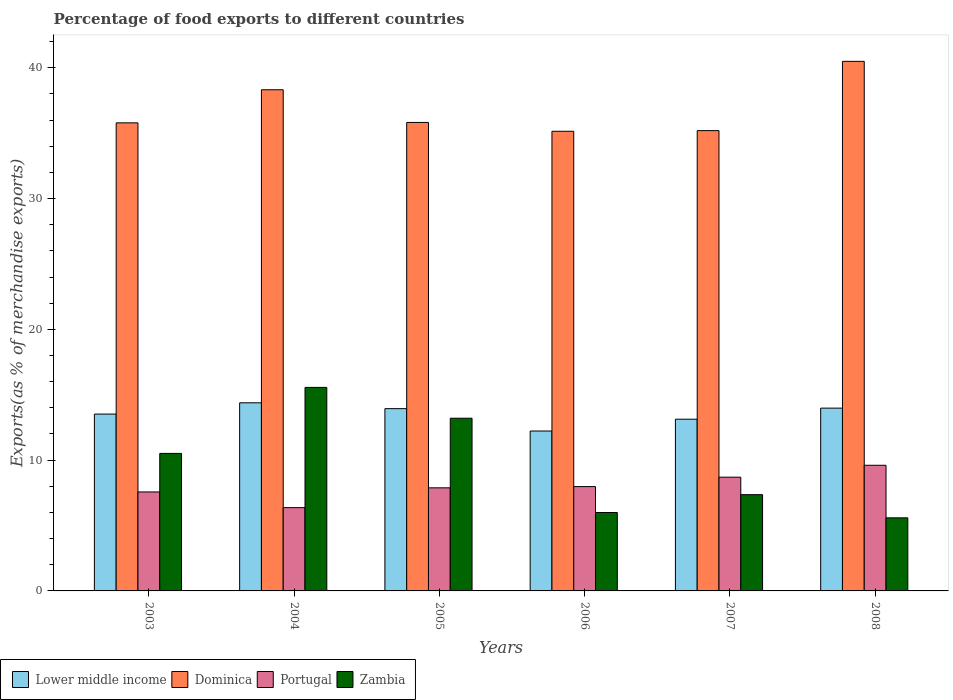How many different coloured bars are there?
Provide a short and direct response. 4. How many groups of bars are there?
Your answer should be compact. 6. Are the number of bars on each tick of the X-axis equal?
Make the answer very short. Yes. What is the label of the 1st group of bars from the left?
Your answer should be very brief. 2003. What is the percentage of exports to different countries in Portugal in 2004?
Give a very brief answer. 6.37. Across all years, what is the maximum percentage of exports to different countries in Dominica?
Offer a terse response. 40.5. Across all years, what is the minimum percentage of exports to different countries in Zambia?
Your answer should be compact. 5.59. What is the total percentage of exports to different countries in Lower middle income in the graph?
Ensure brevity in your answer.  81.18. What is the difference between the percentage of exports to different countries in Dominica in 2003 and that in 2006?
Provide a succinct answer. 0.64. What is the difference between the percentage of exports to different countries in Zambia in 2005 and the percentage of exports to different countries in Portugal in 2004?
Offer a terse response. 6.84. What is the average percentage of exports to different countries in Portugal per year?
Keep it short and to the point. 8.02. In the year 2005, what is the difference between the percentage of exports to different countries in Portugal and percentage of exports to different countries in Zambia?
Your answer should be very brief. -5.32. What is the ratio of the percentage of exports to different countries in Lower middle income in 2007 to that in 2008?
Provide a short and direct response. 0.94. Is the percentage of exports to different countries in Zambia in 2003 less than that in 2004?
Give a very brief answer. Yes. What is the difference between the highest and the second highest percentage of exports to different countries in Dominica?
Offer a very short reply. 2.17. What is the difference between the highest and the lowest percentage of exports to different countries in Zambia?
Ensure brevity in your answer.  9.97. In how many years, is the percentage of exports to different countries in Zambia greater than the average percentage of exports to different countries in Zambia taken over all years?
Provide a succinct answer. 3. Is the sum of the percentage of exports to different countries in Zambia in 2004 and 2005 greater than the maximum percentage of exports to different countries in Portugal across all years?
Your answer should be very brief. Yes. What does the 3rd bar from the left in 2006 represents?
Make the answer very short. Portugal. Is it the case that in every year, the sum of the percentage of exports to different countries in Dominica and percentage of exports to different countries in Lower middle income is greater than the percentage of exports to different countries in Zambia?
Your response must be concise. Yes. Are all the bars in the graph horizontal?
Provide a succinct answer. No. What is the difference between two consecutive major ticks on the Y-axis?
Give a very brief answer. 10. How many legend labels are there?
Your answer should be compact. 4. How are the legend labels stacked?
Provide a succinct answer. Horizontal. What is the title of the graph?
Offer a terse response. Percentage of food exports to different countries. What is the label or title of the X-axis?
Provide a short and direct response. Years. What is the label or title of the Y-axis?
Offer a very short reply. Exports(as % of merchandise exports). What is the Exports(as % of merchandise exports) of Lower middle income in 2003?
Provide a succinct answer. 13.52. What is the Exports(as % of merchandise exports) in Dominica in 2003?
Ensure brevity in your answer.  35.79. What is the Exports(as % of merchandise exports) of Portugal in 2003?
Offer a terse response. 7.57. What is the Exports(as % of merchandise exports) of Zambia in 2003?
Offer a very short reply. 10.52. What is the Exports(as % of merchandise exports) of Lower middle income in 2004?
Ensure brevity in your answer.  14.38. What is the Exports(as % of merchandise exports) of Dominica in 2004?
Ensure brevity in your answer.  38.32. What is the Exports(as % of merchandise exports) in Portugal in 2004?
Your response must be concise. 6.37. What is the Exports(as % of merchandise exports) in Zambia in 2004?
Give a very brief answer. 15.56. What is the Exports(as % of merchandise exports) of Lower middle income in 2005?
Ensure brevity in your answer.  13.94. What is the Exports(as % of merchandise exports) in Dominica in 2005?
Keep it short and to the point. 35.83. What is the Exports(as % of merchandise exports) in Portugal in 2005?
Keep it short and to the point. 7.88. What is the Exports(as % of merchandise exports) in Zambia in 2005?
Your answer should be compact. 13.21. What is the Exports(as % of merchandise exports) of Lower middle income in 2006?
Offer a very short reply. 12.23. What is the Exports(as % of merchandise exports) in Dominica in 2006?
Your answer should be very brief. 35.15. What is the Exports(as % of merchandise exports) of Portugal in 2006?
Provide a succinct answer. 7.98. What is the Exports(as % of merchandise exports) in Zambia in 2006?
Keep it short and to the point. 6. What is the Exports(as % of merchandise exports) in Lower middle income in 2007?
Your answer should be compact. 13.13. What is the Exports(as % of merchandise exports) of Dominica in 2007?
Provide a short and direct response. 35.2. What is the Exports(as % of merchandise exports) of Portugal in 2007?
Provide a short and direct response. 8.7. What is the Exports(as % of merchandise exports) in Zambia in 2007?
Your answer should be very brief. 7.36. What is the Exports(as % of merchandise exports) of Lower middle income in 2008?
Provide a short and direct response. 13.98. What is the Exports(as % of merchandise exports) of Dominica in 2008?
Your answer should be compact. 40.5. What is the Exports(as % of merchandise exports) in Portugal in 2008?
Offer a very short reply. 9.61. What is the Exports(as % of merchandise exports) of Zambia in 2008?
Your response must be concise. 5.59. Across all years, what is the maximum Exports(as % of merchandise exports) of Lower middle income?
Keep it short and to the point. 14.38. Across all years, what is the maximum Exports(as % of merchandise exports) in Dominica?
Provide a succinct answer. 40.5. Across all years, what is the maximum Exports(as % of merchandise exports) of Portugal?
Make the answer very short. 9.61. Across all years, what is the maximum Exports(as % of merchandise exports) of Zambia?
Offer a terse response. 15.56. Across all years, what is the minimum Exports(as % of merchandise exports) in Lower middle income?
Make the answer very short. 12.23. Across all years, what is the minimum Exports(as % of merchandise exports) of Dominica?
Provide a short and direct response. 35.15. Across all years, what is the minimum Exports(as % of merchandise exports) of Portugal?
Ensure brevity in your answer.  6.37. Across all years, what is the minimum Exports(as % of merchandise exports) in Zambia?
Your answer should be very brief. 5.59. What is the total Exports(as % of merchandise exports) in Lower middle income in the graph?
Make the answer very short. 81.18. What is the total Exports(as % of merchandise exports) of Dominica in the graph?
Ensure brevity in your answer.  220.79. What is the total Exports(as % of merchandise exports) of Portugal in the graph?
Ensure brevity in your answer.  48.11. What is the total Exports(as % of merchandise exports) in Zambia in the graph?
Give a very brief answer. 58.23. What is the difference between the Exports(as % of merchandise exports) in Lower middle income in 2003 and that in 2004?
Provide a succinct answer. -0.86. What is the difference between the Exports(as % of merchandise exports) of Dominica in 2003 and that in 2004?
Provide a short and direct response. -2.53. What is the difference between the Exports(as % of merchandise exports) of Portugal in 2003 and that in 2004?
Provide a succinct answer. 1.2. What is the difference between the Exports(as % of merchandise exports) in Zambia in 2003 and that in 2004?
Offer a terse response. -5.05. What is the difference between the Exports(as % of merchandise exports) in Lower middle income in 2003 and that in 2005?
Offer a very short reply. -0.41. What is the difference between the Exports(as % of merchandise exports) of Dominica in 2003 and that in 2005?
Provide a succinct answer. -0.03. What is the difference between the Exports(as % of merchandise exports) of Portugal in 2003 and that in 2005?
Give a very brief answer. -0.31. What is the difference between the Exports(as % of merchandise exports) in Zambia in 2003 and that in 2005?
Offer a terse response. -2.69. What is the difference between the Exports(as % of merchandise exports) in Lower middle income in 2003 and that in 2006?
Give a very brief answer. 1.3. What is the difference between the Exports(as % of merchandise exports) of Dominica in 2003 and that in 2006?
Offer a very short reply. 0.64. What is the difference between the Exports(as % of merchandise exports) of Portugal in 2003 and that in 2006?
Provide a short and direct response. -0.41. What is the difference between the Exports(as % of merchandise exports) of Zambia in 2003 and that in 2006?
Provide a short and direct response. 4.52. What is the difference between the Exports(as % of merchandise exports) of Lower middle income in 2003 and that in 2007?
Give a very brief answer. 0.39. What is the difference between the Exports(as % of merchandise exports) in Dominica in 2003 and that in 2007?
Keep it short and to the point. 0.59. What is the difference between the Exports(as % of merchandise exports) in Portugal in 2003 and that in 2007?
Offer a very short reply. -1.13. What is the difference between the Exports(as % of merchandise exports) of Zambia in 2003 and that in 2007?
Offer a terse response. 3.15. What is the difference between the Exports(as % of merchandise exports) of Lower middle income in 2003 and that in 2008?
Provide a short and direct response. -0.45. What is the difference between the Exports(as % of merchandise exports) in Dominica in 2003 and that in 2008?
Provide a succinct answer. -4.7. What is the difference between the Exports(as % of merchandise exports) in Portugal in 2003 and that in 2008?
Give a very brief answer. -2.04. What is the difference between the Exports(as % of merchandise exports) of Zambia in 2003 and that in 2008?
Your answer should be compact. 4.93. What is the difference between the Exports(as % of merchandise exports) in Lower middle income in 2004 and that in 2005?
Offer a terse response. 0.45. What is the difference between the Exports(as % of merchandise exports) in Dominica in 2004 and that in 2005?
Provide a succinct answer. 2.5. What is the difference between the Exports(as % of merchandise exports) of Portugal in 2004 and that in 2005?
Give a very brief answer. -1.51. What is the difference between the Exports(as % of merchandise exports) of Zambia in 2004 and that in 2005?
Keep it short and to the point. 2.36. What is the difference between the Exports(as % of merchandise exports) of Lower middle income in 2004 and that in 2006?
Your answer should be compact. 2.16. What is the difference between the Exports(as % of merchandise exports) of Dominica in 2004 and that in 2006?
Your response must be concise. 3.18. What is the difference between the Exports(as % of merchandise exports) of Portugal in 2004 and that in 2006?
Provide a succinct answer. -1.61. What is the difference between the Exports(as % of merchandise exports) of Zambia in 2004 and that in 2006?
Give a very brief answer. 9.57. What is the difference between the Exports(as % of merchandise exports) of Lower middle income in 2004 and that in 2007?
Your response must be concise. 1.25. What is the difference between the Exports(as % of merchandise exports) of Dominica in 2004 and that in 2007?
Keep it short and to the point. 3.12. What is the difference between the Exports(as % of merchandise exports) in Portugal in 2004 and that in 2007?
Ensure brevity in your answer.  -2.33. What is the difference between the Exports(as % of merchandise exports) of Zambia in 2004 and that in 2007?
Provide a short and direct response. 8.2. What is the difference between the Exports(as % of merchandise exports) of Lower middle income in 2004 and that in 2008?
Your answer should be very brief. 0.41. What is the difference between the Exports(as % of merchandise exports) in Dominica in 2004 and that in 2008?
Keep it short and to the point. -2.17. What is the difference between the Exports(as % of merchandise exports) in Portugal in 2004 and that in 2008?
Your answer should be very brief. -3.24. What is the difference between the Exports(as % of merchandise exports) of Zambia in 2004 and that in 2008?
Make the answer very short. 9.97. What is the difference between the Exports(as % of merchandise exports) in Lower middle income in 2005 and that in 2006?
Your answer should be very brief. 1.71. What is the difference between the Exports(as % of merchandise exports) of Dominica in 2005 and that in 2006?
Keep it short and to the point. 0.68. What is the difference between the Exports(as % of merchandise exports) of Portugal in 2005 and that in 2006?
Your response must be concise. -0.09. What is the difference between the Exports(as % of merchandise exports) in Zambia in 2005 and that in 2006?
Your answer should be compact. 7.21. What is the difference between the Exports(as % of merchandise exports) of Lower middle income in 2005 and that in 2007?
Your answer should be very brief. 0.81. What is the difference between the Exports(as % of merchandise exports) in Dominica in 2005 and that in 2007?
Your answer should be very brief. 0.63. What is the difference between the Exports(as % of merchandise exports) of Portugal in 2005 and that in 2007?
Your answer should be very brief. -0.82. What is the difference between the Exports(as % of merchandise exports) in Zambia in 2005 and that in 2007?
Your answer should be very brief. 5.85. What is the difference between the Exports(as % of merchandise exports) of Lower middle income in 2005 and that in 2008?
Offer a very short reply. -0.04. What is the difference between the Exports(as % of merchandise exports) in Dominica in 2005 and that in 2008?
Provide a succinct answer. -4.67. What is the difference between the Exports(as % of merchandise exports) in Portugal in 2005 and that in 2008?
Ensure brevity in your answer.  -1.73. What is the difference between the Exports(as % of merchandise exports) of Zambia in 2005 and that in 2008?
Provide a succinct answer. 7.62. What is the difference between the Exports(as % of merchandise exports) of Lower middle income in 2006 and that in 2007?
Offer a very short reply. -0.91. What is the difference between the Exports(as % of merchandise exports) of Dominica in 2006 and that in 2007?
Provide a succinct answer. -0.05. What is the difference between the Exports(as % of merchandise exports) in Portugal in 2006 and that in 2007?
Give a very brief answer. -0.72. What is the difference between the Exports(as % of merchandise exports) of Zambia in 2006 and that in 2007?
Provide a succinct answer. -1.36. What is the difference between the Exports(as % of merchandise exports) of Lower middle income in 2006 and that in 2008?
Ensure brevity in your answer.  -1.75. What is the difference between the Exports(as % of merchandise exports) in Dominica in 2006 and that in 2008?
Ensure brevity in your answer.  -5.35. What is the difference between the Exports(as % of merchandise exports) of Portugal in 2006 and that in 2008?
Your response must be concise. -1.63. What is the difference between the Exports(as % of merchandise exports) of Zambia in 2006 and that in 2008?
Keep it short and to the point. 0.41. What is the difference between the Exports(as % of merchandise exports) of Lower middle income in 2007 and that in 2008?
Your response must be concise. -0.85. What is the difference between the Exports(as % of merchandise exports) of Dominica in 2007 and that in 2008?
Your answer should be compact. -5.3. What is the difference between the Exports(as % of merchandise exports) of Portugal in 2007 and that in 2008?
Your answer should be very brief. -0.91. What is the difference between the Exports(as % of merchandise exports) in Zambia in 2007 and that in 2008?
Your response must be concise. 1.77. What is the difference between the Exports(as % of merchandise exports) of Lower middle income in 2003 and the Exports(as % of merchandise exports) of Dominica in 2004?
Your answer should be compact. -24.8. What is the difference between the Exports(as % of merchandise exports) of Lower middle income in 2003 and the Exports(as % of merchandise exports) of Portugal in 2004?
Offer a terse response. 7.15. What is the difference between the Exports(as % of merchandise exports) in Lower middle income in 2003 and the Exports(as % of merchandise exports) in Zambia in 2004?
Your answer should be compact. -2.04. What is the difference between the Exports(as % of merchandise exports) of Dominica in 2003 and the Exports(as % of merchandise exports) of Portugal in 2004?
Your response must be concise. 29.42. What is the difference between the Exports(as % of merchandise exports) of Dominica in 2003 and the Exports(as % of merchandise exports) of Zambia in 2004?
Your response must be concise. 20.23. What is the difference between the Exports(as % of merchandise exports) in Portugal in 2003 and the Exports(as % of merchandise exports) in Zambia in 2004?
Make the answer very short. -7.99. What is the difference between the Exports(as % of merchandise exports) of Lower middle income in 2003 and the Exports(as % of merchandise exports) of Dominica in 2005?
Offer a very short reply. -22.3. What is the difference between the Exports(as % of merchandise exports) of Lower middle income in 2003 and the Exports(as % of merchandise exports) of Portugal in 2005?
Offer a very short reply. 5.64. What is the difference between the Exports(as % of merchandise exports) of Lower middle income in 2003 and the Exports(as % of merchandise exports) of Zambia in 2005?
Keep it short and to the point. 0.32. What is the difference between the Exports(as % of merchandise exports) of Dominica in 2003 and the Exports(as % of merchandise exports) of Portugal in 2005?
Provide a succinct answer. 27.91. What is the difference between the Exports(as % of merchandise exports) in Dominica in 2003 and the Exports(as % of merchandise exports) in Zambia in 2005?
Offer a terse response. 22.59. What is the difference between the Exports(as % of merchandise exports) in Portugal in 2003 and the Exports(as % of merchandise exports) in Zambia in 2005?
Keep it short and to the point. -5.64. What is the difference between the Exports(as % of merchandise exports) in Lower middle income in 2003 and the Exports(as % of merchandise exports) in Dominica in 2006?
Offer a terse response. -21.63. What is the difference between the Exports(as % of merchandise exports) in Lower middle income in 2003 and the Exports(as % of merchandise exports) in Portugal in 2006?
Make the answer very short. 5.55. What is the difference between the Exports(as % of merchandise exports) of Lower middle income in 2003 and the Exports(as % of merchandise exports) of Zambia in 2006?
Offer a terse response. 7.53. What is the difference between the Exports(as % of merchandise exports) in Dominica in 2003 and the Exports(as % of merchandise exports) in Portugal in 2006?
Your answer should be compact. 27.82. What is the difference between the Exports(as % of merchandise exports) in Dominica in 2003 and the Exports(as % of merchandise exports) in Zambia in 2006?
Provide a short and direct response. 29.8. What is the difference between the Exports(as % of merchandise exports) in Portugal in 2003 and the Exports(as % of merchandise exports) in Zambia in 2006?
Your answer should be compact. 1.57. What is the difference between the Exports(as % of merchandise exports) in Lower middle income in 2003 and the Exports(as % of merchandise exports) in Dominica in 2007?
Provide a succinct answer. -21.68. What is the difference between the Exports(as % of merchandise exports) of Lower middle income in 2003 and the Exports(as % of merchandise exports) of Portugal in 2007?
Your response must be concise. 4.83. What is the difference between the Exports(as % of merchandise exports) in Lower middle income in 2003 and the Exports(as % of merchandise exports) in Zambia in 2007?
Keep it short and to the point. 6.16. What is the difference between the Exports(as % of merchandise exports) of Dominica in 2003 and the Exports(as % of merchandise exports) of Portugal in 2007?
Offer a terse response. 27.1. What is the difference between the Exports(as % of merchandise exports) in Dominica in 2003 and the Exports(as % of merchandise exports) in Zambia in 2007?
Provide a short and direct response. 28.43. What is the difference between the Exports(as % of merchandise exports) of Portugal in 2003 and the Exports(as % of merchandise exports) of Zambia in 2007?
Your response must be concise. 0.21. What is the difference between the Exports(as % of merchandise exports) of Lower middle income in 2003 and the Exports(as % of merchandise exports) of Dominica in 2008?
Give a very brief answer. -26.97. What is the difference between the Exports(as % of merchandise exports) in Lower middle income in 2003 and the Exports(as % of merchandise exports) in Portugal in 2008?
Your response must be concise. 3.92. What is the difference between the Exports(as % of merchandise exports) in Lower middle income in 2003 and the Exports(as % of merchandise exports) in Zambia in 2008?
Ensure brevity in your answer.  7.94. What is the difference between the Exports(as % of merchandise exports) of Dominica in 2003 and the Exports(as % of merchandise exports) of Portugal in 2008?
Make the answer very short. 26.18. What is the difference between the Exports(as % of merchandise exports) of Dominica in 2003 and the Exports(as % of merchandise exports) of Zambia in 2008?
Keep it short and to the point. 30.21. What is the difference between the Exports(as % of merchandise exports) of Portugal in 2003 and the Exports(as % of merchandise exports) of Zambia in 2008?
Offer a very short reply. 1.98. What is the difference between the Exports(as % of merchandise exports) of Lower middle income in 2004 and the Exports(as % of merchandise exports) of Dominica in 2005?
Make the answer very short. -21.44. What is the difference between the Exports(as % of merchandise exports) of Lower middle income in 2004 and the Exports(as % of merchandise exports) of Portugal in 2005?
Keep it short and to the point. 6.5. What is the difference between the Exports(as % of merchandise exports) of Lower middle income in 2004 and the Exports(as % of merchandise exports) of Zambia in 2005?
Make the answer very short. 1.18. What is the difference between the Exports(as % of merchandise exports) of Dominica in 2004 and the Exports(as % of merchandise exports) of Portugal in 2005?
Make the answer very short. 30.44. What is the difference between the Exports(as % of merchandise exports) in Dominica in 2004 and the Exports(as % of merchandise exports) in Zambia in 2005?
Make the answer very short. 25.12. What is the difference between the Exports(as % of merchandise exports) of Portugal in 2004 and the Exports(as % of merchandise exports) of Zambia in 2005?
Offer a terse response. -6.84. What is the difference between the Exports(as % of merchandise exports) in Lower middle income in 2004 and the Exports(as % of merchandise exports) in Dominica in 2006?
Your response must be concise. -20.76. What is the difference between the Exports(as % of merchandise exports) of Lower middle income in 2004 and the Exports(as % of merchandise exports) of Portugal in 2006?
Make the answer very short. 6.41. What is the difference between the Exports(as % of merchandise exports) of Lower middle income in 2004 and the Exports(as % of merchandise exports) of Zambia in 2006?
Your answer should be very brief. 8.39. What is the difference between the Exports(as % of merchandise exports) in Dominica in 2004 and the Exports(as % of merchandise exports) in Portugal in 2006?
Your answer should be very brief. 30.35. What is the difference between the Exports(as % of merchandise exports) of Dominica in 2004 and the Exports(as % of merchandise exports) of Zambia in 2006?
Your response must be concise. 32.33. What is the difference between the Exports(as % of merchandise exports) of Portugal in 2004 and the Exports(as % of merchandise exports) of Zambia in 2006?
Give a very brief answer. 0.37. What is the difference between the Exports(as % of merchandise exports) in Lower middle income in 2004 and the Exports(as % of merchandise exports) in Dominica in 2007?
Make the answer very short. -20.82. What is the difference between the Exports(as % of merchandise exports) in Lower middle income in 2004 and the Exports(as % of merchandise exports) in Portugal in 2007?
Keep it short and to the point. 5.69. What is the difference between the Exports(as % of merchandise exports) of Lower middle income in 2004 and the Exports(as % of merchandise exports) of Zambia in 2007?
Make the answer very short. 7.02. What is the difference between the Exports(as % of merchandise exports) of Dominica in 2004 and the Exports(as % of merchandise exports) of Portugal in 2007?
Your answer should be very brief. 29.63. What is the difference between the Exports(as % of merchandise exports) of Dominica in 2004 and the Exports(as % of merchandise exports) of Zambia in 2007?
Make the answer very short. 30.96. What is the difference between the Exports(as % of merchandise exports) in Portugal in 2004 and the Exports(as % of merchandise exports) in Zambia in 2007?
Offer a terse response. -0.99. What is the difference between the Exports(as % of merchandise exports) in Lower middle income in 2004 and the Exports(as % of merchandise exports) in Dominica in 2008?
Give a very brief answer. -26.11. What is the difference between the Exports(as % of merchandise exports) of Lower middle income in 2004 and the Exports(as % of merchandise exports) of Portugal in 2008?
Give a very brief answer. 4.78. What is the difference between the Exports(as % of merchandise exports) in Lower middle income in 2004 and the Exports(as % of merchandise exports) in Zambia in 2008?
Ensure brevity in your answer.  8.8. What is the difference between the Exports(as % of merchandise exports) in Dominica in 2004 and the Exports(as % of merchandise exports) in Portugal in 2008?
Offer a very short reply. 28.72. What is the difference between the Exports(as % of merchandise exports) in Dominica in 2004 and the Exports(as % of merchandise exports) in Zambia in 2008?
Ensure brevity in your answer.  32.74. What is the difference between the Exports(as % of merchandise exports) of Portugal in 2004 and the Exports(as % of merchandise exports) of Zambia in 2008?
Offer a terse response. 0.78. What is the difference between the Exports(as % of merchandise exports) in Lower middle income in 2005 and the Exports(as % of merchandise exports) in Dominica in 2006?
Make the answer very short. -21.21. What is the difference between the Exports(as % of merchandise exports) in Lower middle income in 2005 and the Exports(as % of merchandise exports) in Portugal in 2006?
Ensure brevity in your answer.  5.96. What is the difference between the Exports(as % of merchandise exports) of Lower middle income in 2005 and the Exports(as % of merchandise exports) of Zambia in 2006?
Keep it short and to the point. 7.94. What is the difference between the Exports(as % of merchandise exports) of Dominica in 2005 and the Exports(as % of merchandise exports) of Portugal in 2006?
Offer a terse response. 27.85. What is the difference between the Exports(as % of merchandise exports) of Dominica in 2005 and the Exports(as % of merchandise exports) of Zambia in 2006?
Offer a very short reply. 29.83. What is the difference between the Exports(as % of merchandise exports) of Portugal in 2005 and the Exports(as % of merchandise exports) of Zambia in 2006?
Ensure brevity in your answer.  1.89. What is the difference between the Exports(as % of merchandise exports) of Lower middle income in 2005 and the Exports(as % of merchandise exports) of Dominica in 2007?
Your answer should be compact. -21.26. What is the difference between the Exports(as % of merchandise exports) of Lower middle income in 2005 and the Exports(as % of merchandise exports) of Portugal in 2007?
Provide a short and direct response. 5.24. What is the difference between the Exports(as % of merchandise exports) in Lower middle income in 2005 and the Exports(as % of merchandise exports) in Zambia in 2007?
Your response must be concise. 6.58. What is the difference between the Exports(as % of merchandise exports) in Dominica in 2005 and the Exports(as % of merchandise exports) in Portugal in 2007?
Your response must be concise. 27.13. What is the difference between the Exports(as % of merchandise exports) of Dominica in 2005 and the Exports(as % of merchandise exports) of Zambia in 2007?
Offer a very short reply. 28.47. What is the difference between the Exports(as % of merchandise exports) of Portugal in 2005 and the Exports(as % of merchandise exports) of Zambia in 2007?
Offer a very short reply. 0.52. What is the difference between the Exports(as % of merchandise exports) in Lower middle income in 2005 and the Exports(as % of merchandise exports) in Dominica in 2008?
Make the answer very short. -26.56. What is the difference between the Exports(as % of merchandise exports) of Lower middle income in 2005 and the Exports(as % of merchandise exports) of Portugal in 2008?
Provide a short and direct response. 4.33. What is the difference between the Exports(as % of merchandise exports) in Lower middle income in 2005 and the Exports(as % of merchandise exports) in Zambia in 2008?
Your response must be concise. 8.35. What is the difference between the Exports(as % of merchandise exports) in Dominica in 2005 and the Exports(as % of merchandise exports) in Portugal in 2008?
Keep it short and to the point. 26.22. What is the difference between the Exports(as % of merchandise exports) in Dominica in 2005 and the Exports(as % of merchandise exports) in Zambia in 2008?
Your response must be concise. 30.24. What is the difference between the Exports(as % of merchandise exports) in Portugal in 2005 and the Exports(as % of merchandise exports) in Zambia in 2008?
Offer a terse response. 2.29. What is the difference between the Exports(as % of merchandise exports) of Lower middle income in 2006 and the Exports(as % of merchandise exports) of Dominica in 2007?
Your response must be concise. -22.97. What is the difference between the Exports(as % of merchandise exports) in Lower middle income in 2006 and the Exports(as % of merchandise exports) in Portugal in 2007?
Your response must be concise. 3.53. What is the difference between the Exports(as % of merchandise exports) of Lower middle income in 2006 and the Exports(as % of merchandise exports) of Zambia in 2007?
Provide a short and direct response. 4.87. What is the difference between the Exports(as % of merchandise exports) of Dominica in 2006 and the Exports(as % of merchandise exports) of Portugal in 2007?
Give a very brief answer. 26.45. What is the difference between the Exports(as % of merchandise exports) in Dominica in 2006 and the Exports(as % of merchandise exports) in Zambia in 2007?
Provide a succinct answer. 27.79. What is the difference between the Exports(as % of merchandise exports) of Portugal in 2006 and the Exports(as % of merchandise exports) of Zambia in 2007?
Your response must be concise. 0.62. What is the difference between the Exports(as % of merchandise exports) of Lower middle income in 2006 and the Exports(as % of merchandise exports) of Dominica in 2008?
Ensure brevity in your answer.  -28.27. What is the difference between the Exports(as % of merchandise exports) in Lower middle income in 2006 and the Exports(as % of merchandise exports) in Portugal in 2008?
Make the answer very short. 2.62. What is the difference between the Exports(as % of merchandise exports) in Lower middle income in 2006 and the Exports(as % of merchandise exports) in Zambia in 2008?
Provide a short and direct response. 6.64. What is the difference between the Exports(as % of merchandise exports) of Dominica in 2006 and the Exports(as % of merchandise exports) of Portugal in 2008?
Your answer should be very brief. 25.54. What is the difference between the Exports(as % of merchandise exports) of Dominica in 2006 and the Exports(as % of merchandise exports) of Zambia in 2008?
Give a very brief answer. 29.56. What is the difference between the Exports(as % of merchandise exports) in Portugal in 2006 and the Exports(as % of merchandise exports) in Zambia in 2008?
Make the answer very short. 2.39. What is the difference between the Exports(as % of merchandise exports) in Lower middle income in 2007 and the Exports(as % of merchandise exports) in Dominica in 2008?
Your answer should be very brief. -27.36. What is the difference between the Exports(as % of merchandise exports) in Lower middle income in 2007 and the Exports(as % of merchandise exports) in Portugal in 2008?
Your answer should be very brief. 3.52. What is the difference between the Exports(as % of merchandise exports) in Lower middle income in 2007 and the Exports(as % of merchandise exports) in Zambia in 2008?
Keep it short and to the point. 7.54. What is the difference between the Exports(as % of merchandise exports) in Dominica in 2007 and the Exports(as % of merchandise exports) in Portugal in 2008?
Ensure brevity in your answer.  25.59. What is the difference between the Exports(as % of merchandise exports) in Dominica in 2007 and the Exports(as % of merchandise exports) in Zambia in 2008?
Your answer should be very brief. 29.61. What is the difference between the Exports(as % of merchandise exports) of Portugal in 2007 and the Exports(as % of merchandise exports) of Zambia in 2008?
Provide a succinct answer. 3.11. What is the average Exports(as % of merchandise exports) of Lower middle income per year?
Your response must be concise. 13.53. What is the average Exports(as % of merchandise exports) of Dominica per year?
Offer a terse response. 36.8. What is the average Exports(as % of merchandise exports) in Portugal per year?
Ensure brevity in your answer.  8.02. What is the average Exports(as % of merchandise exports) in Zambia per year?
Make the answer very short. 9.71. In the year 2003, what is the difference between the Exports(as % of merchandise exports) of Lower middle income and Exports(as % of merchandise exports) of Dominica?
Provide a succinct answer. -22.27. In the year 2003, what is the difference between the Exports(as % of merchandise exports) of Lower middle income and Exports(as % of merchandise exports) of Portugal?
Offer a very short reply. 5.96. In the year 2003, what is the difference between the Exports(as % of merchandise exports) of Lower middle income and Exports(as % of merchandise exports) of Zambia?
Make the answer very short. 3.01. In the year 2003, what is the difference between the Exports(as % of merchandise exports) in Dominica and Exports(as % of merchandise exports) in Portugal?
Ensure brevity in your answer.  28.23. In the year 2003, what is the difference between the Exports(as % of merchandise exports) of Dominica and Exports(as % of merchandise exports) of Zambia?
Give a very brief answer. 25.28. In the year 2003, what is the difference between the Exports(as % of merchandise exports) in Portugal and Exports(as % of merchandise exports) in Zambia?
Your answer should be compact. -2.95. In the year 2004, what is the difference between the Exports(as % of merchandise exports) in Lower middle income and Exports(as % of merchandise exports) in Dominica?
Your response must be concise. -23.94. In the year 2004, what is the difference between the Exports(as % of merchandise exports) of Lower middle income and Exports(as % of merchandise exports) of Portugal?
Provide a short and direct response. 8.02. In the year 2004, what is the difference between the Exports(as % of merchandise exports) of Lower middle income and Exports(as % of merchandise exports) of Zambia?
Your answer should be compact. -1.18. In the year 2004, what is the difference between the Exports(as % of merchandise exports) of Dominica and Exports(as % of merchandise exports) of Portugal?
Your response must be concise. 31.96. In the year 2004, what is the difference between the Exports(as % of merchandise exports) in Dominica and Exports(as % of merchandise exports) in Zambia?
Offer a very short reply. 22.76. In the year 2004, what is the difference between the Exports(as % of merchandise exports) of Portugal and Exports(as % of merchandise exports) of Zambia?
Your answer should be very brief. -9.19. In the year 2005, what is the difference between the Exports(as % of merchandise exports) of Lower middle income and Exports(as % of merchandise exports) of Dominica?
Provide a succinct answer. -21.89. In the year 2005, what is the difference between the Exports(as % of merchandise exports) in Lower middle income and Exports(as % of merchandise exports) in Portugal?
Your answer should be very brief. 6.06. In the year 2005, what is the difference between the Exports(as % of merchandise exports) of Lower middle income and Exports(as % of merchandise exports) of Zambia?
Your answer should be compact. 0.73. In the year 2005, what is the difference between the Exports(as % of merchandise exports) of Dominica and Exports(as % of merchandise exports) of Portugal?
Ensure brevity in your answer.  27.94. In the year 2005, what is the difference between the Exports(as % of merchandise exports) of Dominica and Exports(as % of merchandise exports) of Zambia?
Your answer should be very brief. 22.62. In the year 2005, what is the difference between the Exports(as % of merchandise exports) in Portugal and Exports(as % of merchandise exports) in Zambia?
Your response must be concise. -5.32. In the year 2006, what is the difference between the Exports(as % of merchandise exports) of Lower middle income and Exports(as % of merchandise exports) of Dominica?
Keep it short and to the point. -22.92. In the year 2006, what is the difference between the Exports(as % of merchandise exports) of Lower middle income and Exports(as % of merchandise exports) of Portugal?
Offer a terse response. 4.25. In the year 2006, what is the difference between the Exports(as % of merchandise exports) in Lower middle income and Exports(as % of merchandise exports) in Zambia?
Offer a terse response. 6.23. In the year 2006, what is the difference between the Exports(as % of merchandise exports) in Dominica and Exports(as % of merchandise exports) in Portugal?
Your response must be concise. 27.17. In the year 2006, what is the difference between the Exports(as % of merchandise exports) in Dominica and Exports(as % of merchandise exports) in Zambia?
Your response must be concise. 29.15. In the year 2006, what is the difference between the Exports(as % of merchandise exports) in Portugal and Exports(as % of merchandise exports) in Zambia?
Keep it short and to the point. 1.98. In the year 2007, what is the difference between the Exports(as % of merchandise exports) in Lower middle income and Exports(as % of merchandise exports) in Dominica?
Provide a succinct answer. -22.07. In the year 2007, what is the difference between the Exports(as % of merchandise exports) of Lower middle income and Exports(as % of merchandise exports) of Portugal?
Ensure brevity in your answer.  4.43. In the year 2007, what is the difference between the Exports(as % of merchandise exports) in Lower middle income and Exports(as % of merchandise exports) in Zambia?
Provide a succinct answer. 5.77. In the year 2007, what is the difference between the Exports(as % of merchandise exports) of Dominica and Exports(as % of merchandise exports) of Portugal?
Keep it short and to the point. 26.5. In the year 2007, what is the difference between the Exports(as % of merchandise exports) of Dominica and Exports(as % of merchandise exports) of Zambia?
Your answer should be very brief. 27.84. In the year 2007, what is the difference between the Exports(as % of merchandise exports) of Portugal and Exports(as % of merchandise exports) of Zambia?
Provide a succinct answer. 1.34. In the year 2008, what is the difference between the Exports(as % of merchandise exports) of Lower middle income and Exports(as % of merchandise exports) of Dominica?
Ensure brevity in your answer.  -26.52. In the year 2008, what is the difference between the Exports(as % of merchandise exports) in Lower middle income and Exports(as % of merchandise exports) in Portugal?
Offer a very short reply. 4.37. In the year 2008, what is the difference between the Exports(as % of merchandise exports) of Lower middle income and Exports(as % of merchandise exports) of Zambia?
Your answer should be very brief. 8.39. In the year 2008, what is the difference between the Exports(as % of merchandise exports) of Dominica and Exports(as % of merchandise exports) of Portugal?
Ensure brevity in your answer.  30.89. In the year 2008, what is the difference between the Exports(as % of merchandise exports) in Dominica and Exports(as % of merchandise exports) in Zambia?
Provide a short and direct response. 34.91. In the year 2008, what is the difference between the Exports(as % of merchandise exports) in Portugal and Exports(as % of merchandise exports) in Zambia?
Offer a very short reply. 4.02. What is the ratio of the Exports(as % of merchandise exports) of Lower middle income in 2003 to that in 2004?
Ensure brevity in your answer.  0.94. What is the ratio of the Exports(as % of merchandise exports) in Dominica in 2003 to that in 2004?
Provide a short and direct response. 0.93. What is the ratio of the Exports(as % of merchandise exports) of Portugal in 2003 to that in 2004?
Ensure brevity in your answer.  1.19. What is the ratio of the Exports(as % of merchandise exports) in Zambia in 2003 to that in 2004?
Your answer should be compact. 0.68. What is the ratio of the Exports(as % of merchandise exports) of Lower middle income in 2003 to that in 2005?
Offer a very short reply. 0.97. What is the ratio of the Exports(as % of merchandise exports) of Portugal in 2003 to that in 2005?
Your answer should be compact. 0.96. What is the ratio of the Exports(as % of merchandise exports) in Zambia in 2003 to that in 2005?
Your response must be concise. 0.8. What is the ratio of the Exports(as % of merchandise exports) in Lower middle income in 2003 to that in 2006?
Offer a very short reply. 1.11. What is the ratio of the Exports(as % of merchandise exports) in Dominica in 2003 to that in 2006?
Your response must be concise. 1.02. What is the ratio of the Exports(as % of merchandise exports) in Portugal in 2003 to that in 2006?
Make the answer very short. 0.95. What is the ratio of the Exports(as % of merchandise exports) of Zambia in 2003 to that in 2006?
Make the answer very short. 1.75. What is the ratio of the Exports(as % of merchandise exports) of Lower middle income in 2003 to that in 2007?
Your answer should be very brief. 1.03. What is the ratio of the Exports(as % of merchandise exports) of Dominica in 2003 to that in 2007?
Offer a very short reply. 1.02. What is the ratio of the Exports(as % of merchandise exports) of Portugal in 2003 to that in 2007?
Keep it short and to the point. 0.87. What is the ratio of the Exports(as % of merchandise exports) in Zambia in 2003 to that in 2007?
Offer a very short reply. 1.43. What is the ratio of the Exports(as % of merchandise exports) of Lower middle income in 2003 to that in 2008?
Your answer should be compact. 0.97. What is the ratio of the Exports(as % of merchandise exports) in Dominica in 2003 to that in 2008?
Keep it short and to the point. 0.88. What is the ratio of the Exports(as % of merchandise exports) of Portugal in 2003 to that in 2008?
Give a very brief answer. 0.79. What is the ratio of the Exports(as % of merchandise exports) of Zambia in 2003 to that in 2008?
Provide a succinct answer. 1.88. What is the ratio of the Exports(as % of merchandise exports) in Lower middle income in 2004 to that in 2005?
Give a very brief answer. 1.03. What is the ratio of the Exports(as % of merchandise exports) in Dominica in 2004 to that in 2005?
Provide a short and direct response. 1.07. What is the ratio of the Exports(as % of merchandise exports) in Portugal in 2004 to that in 2005?
Provide a succinct answer. 0.81. What is the ratio of the Exports(as % of merchandise exports) in Zambia in 2004 to that in 2005?
Ensure brevity in your answer.  1.18. What is the ratio of the Exports(as % of merchandise exports) of Lower middle income in 2004 to that in 2006?
Provide a short and direct response. 1.18. What is the ratio of the Exports(as % of merchandise exports) in Dominica in 2004 to that in 2006?
Provide a short and direct response. 1.09. What is the ratio of the Exports(as % of merchandise exports) of Portugal in 2004 to that in 2006?
Make the answer very short. 0.8. What is the ratio of the Exports(as % of merchandise exports) of Zambia in 2004 to that in 2006?
Your answer should be compact. 2.6. What is the ratio of the Exports(as % of merchandise exports) in Lower middle income in 2004 to that in 2007?
Your response must be concise. 1.1. What is the ratio of the Exports(as % of merchandise exports) of Dominica in 2004 to that in 2007?
Your answer should be compact. 1.09. What is the ratio of the Exports(as % of merchandise exports) in Portugal in 2004 to that in 2007?
Offer a terse response. 0.73. What is the ratio of the Exports(as % of merchandise exports) in Zambia in 2004 to that in 2007?
Your answer should be very brief. 2.11. What is the ratio of the Exports(as % of merchandise exports) in Lower middle income in 2004 to that in 2008?
Provide a short and direct response. 1.03. What is the ratio of the Exports(as % of merchandise exports) of Dominica in 2004 to that in 2008?
Ensure brevity in your answer.  0.95. What is the ratio of the Exports(as % of merchandise exports) in Portugal in 2004 to that in 2008?
Your answer should be compact. 0.66. What is the ratio of the Exports(as % of merchandise exports) of Zambia in 2004 to that in 2008?
Ensure brevity in your answer.  2.78. What is the ratio of the Exports(as % of merchandise exports) in Lower middle income in 2005 to that in 2006?
Keep it short and to the point. 1.14. What is the ratio of the Exports(as % of merchandise exports) of Dominica in 2005 to that in 2006?
Make the answer very short. 1.02. What is the ratio of the Exports(as % of merchandise exports) of Zambia in 2005 to that in 2006?
Keep it short and to the point. 2.2. What is the ratio of the Exports(as % of merchandise exports) of Lower middle income in 2005 to that in 2007?
Make the answer very short. 1.06. What is the ratio of the Exports(as % of merchandise exports) of Dominica in 2005 to that in 2007?
Make the answer very short. 1.02. What is the ratio of the Exports(as % of merchandise exports) of Portugal in 2005 to that in 2007?
Keep it short and to the point. 0.91. What is the ratio of the Exports(as % of merchandise exports) in Zambia in 2005 to that in 2007?
Provide a short and direct response. 1.79. What is the ratio of the Exports(as % of merchandise exports) of Dominica in 2005 to that in 2008?
Your answer should be very brief. 0.88. What is the ratio of the Exports(as % of merchandise exports) of Portugal in 2005 to that in 2008?
Offer a terse response. 0.82. What is the ratio of the Exports(as % of merchandise exports) of Zambia in 2005 to that in 2008?
Your answer should be very brief. 2.36. What is the ratio of the Exports(as % of merchandise exports) of Lower middle income in 2006 to that in 2007?
Provide a short and direct response. 0.93. What is the ratio of the Exports(as % of merchandise exports) in Dominica in 2006 to that in 2007?
Offer a terse response. 1. What is the ratio of the Exports(as % of merchandise exports) of Portugal in 2006 to that in 2007?
Make the answer very short. 0.92. What is the ratio of the Exports(as % of merchandise exports) in Zambia in 2006 to that in 2007?
Your response must be concise. 0.81. What is the ratio of the Exports(as % of merchandise exports) in Lower middle income in 2006 to that in 2008?
Give a very brief answer. 0.87. What is the ratio of the Exports(as % of merchandise exports) of Dominica in 2006 to that in 2008?
Offer a terse response. 0.87. What is the ratio of the Exports(as % of merchandise exports) in Portugal in 2006 to that in 2008?
Make the answer very short. 0.83. What is the ratio of the Exports(as % of merchandise exports) in Zambia in 2006 to that in 2008?
Offer a terse response. 1.07. What is the ratio of the Exports(as % of merchandise exports) in Lower middle income in 2007 to that in 2008?
Ensure brevity in your answer.  0.94. What is the ratio of the Exports(as % of merchandise exports) of Dominica in 2007 to that in 2008?
Your answer should be very brief. 0.87. What is the ratio of the Exports(as % of merchandise exports) in Portugal in 2007 to that in 2008?
Offer a very short reply. 0.91. What is the ratio of the Exports(as % of merchandise exports) in Zambia in 2007 to that in 2008?
Make the answer very short. 1.32. What is the difference between the highest and the second highest Exports(as % of merchandise exports) of Lower middle income?
Offer a terse response. 0.41. What is the difference between the highest and the second highest Exports(as % of merchandise exports) of Dominica?
Give a very brief answer. 2.17. What is the difference between the highest and the second highest Exports(as % of merchandise exports) in Portugal?
Offer a terse response. 0.91. What is the difference between the highest and the second highest Exports(as % of merchandise exports) in Zambia?
Make the answer very short. 2.36. What is the difference between the highest and the lowest Exports(as % of merchandise exports) of Lower middle income?
Provide a succinct answer. 2.16. What is the difference between the highest and the lowest Exports(as % of merchandise exports) of Dominica?
Give a very brief answer. 5.35. What is the difference between the highest and the lowest Exports(as % of merchandise exports) in Portugal?
Offer a very short reply. 3.24. What is the difference between the highest and the lowest Exports(as % of merchandise exports) of Zambia?
Provide a succinct answer. 9.97. 